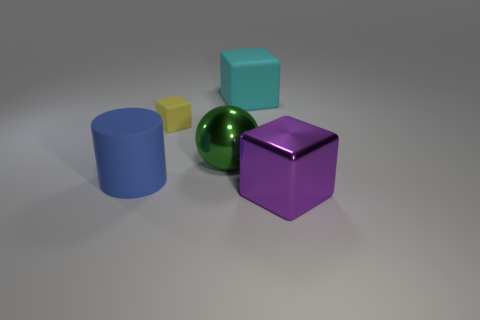Subtract all large cyan rubber blocks. How many blocks are left? 2 Add 4 big green matte balls. How many objects exist? 9 Subtract 1 spheres. How many spheres are left? 0 Subtract all gray cylinders. Subtract all green balls. How many cylinders are left? 1 Subtract all red blocks. How many red spheres are left? 0 Subtract all shiny cubes. Subtract all metallic cubes. How many objects are left? 3 Add 5 tiny yellow matte blocks. How many tiny yellow matte blocks are left? 6 Add 1 small cubes. How many small cubes exist? 2 Subtract all cyan cubes. How many cubes are left? 2 Subtract 1 green spheres. How many objects are left? 4 